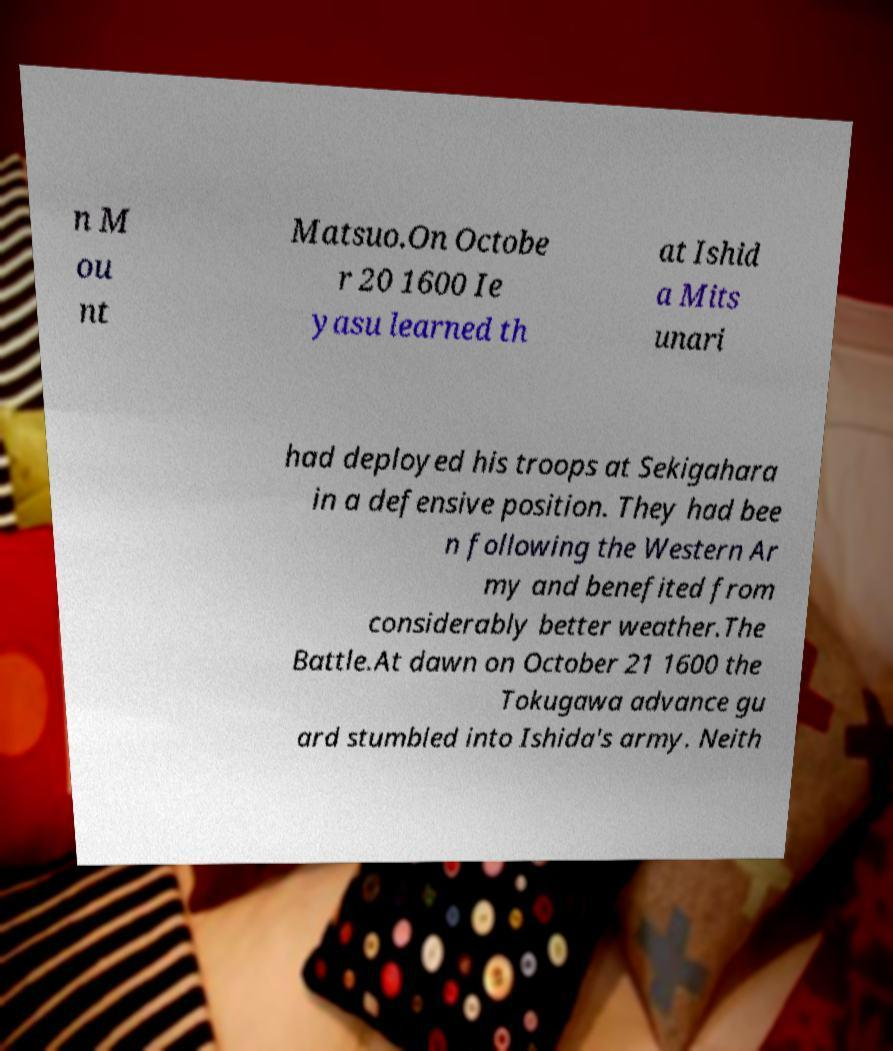Can you read and provide the text displayed in the image?This photo seems to have some interesting text. Can you extract and type it out for me? n M ou nt Matsuo.On Octobe r 20 1600 Ie yasu learned th at Ishid a Mits unari had deployed his troops at Sekigahara in a defensive position. They had bee n following the Western Ar my and benefited from considerably better weather.The Battle.At dawn on October 21 1600 the Tokugawa advance gu ard stumbled into Ishida's army. Neith 